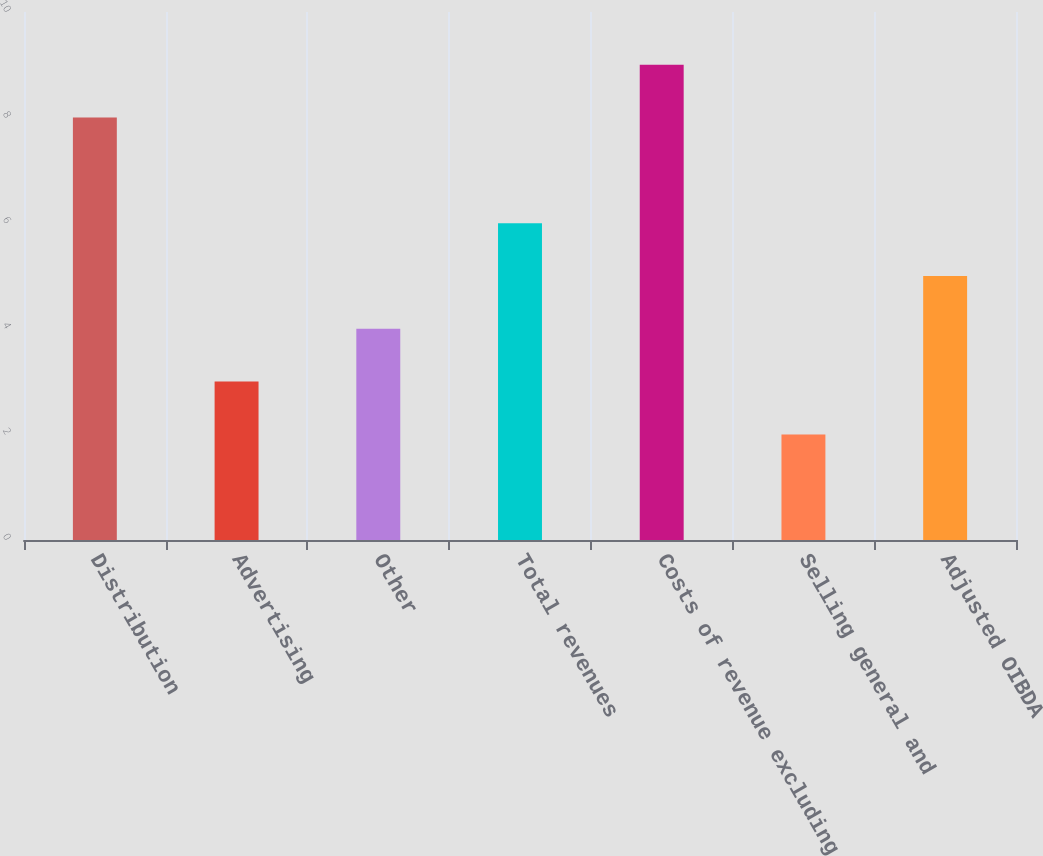Convert chart. <chart><loc_0><loc_0><loc_500><loc_500><bar_chart><fcel>Distribution<fcel>Advertising<fcel>Other<fcel>Total revenues<fcel>Costs of revenue excluding<fcel>Selling general and<fcel>Adjusted OIBDA<nl><fcel>8<fcel>3<fcel>4<fcel>6<fcel>9<fcel>2<fcel>5<nl></chart> 